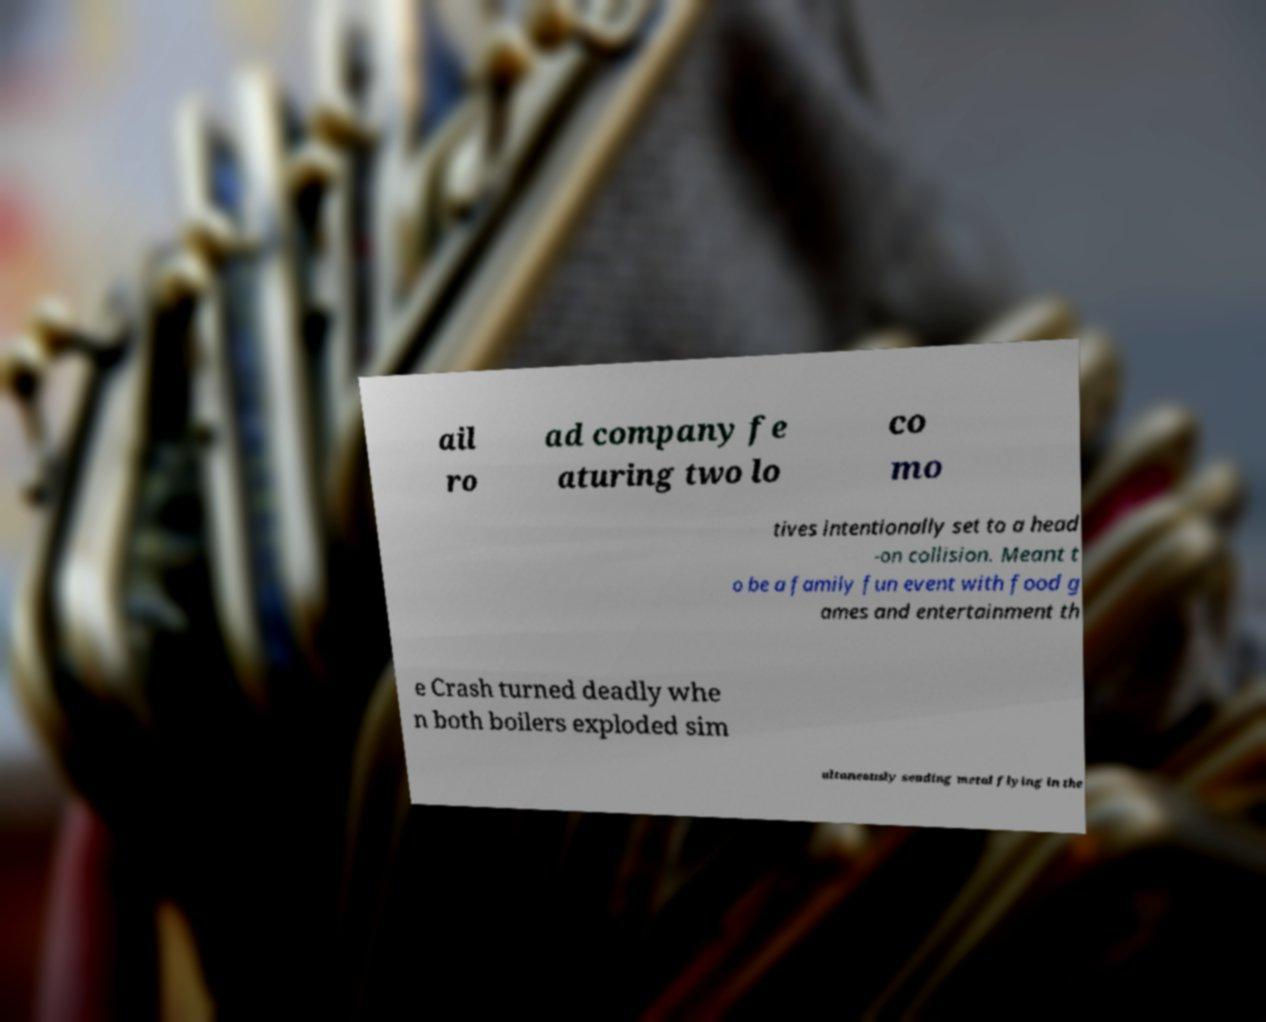For documentation purposes, I need the text within this image transcribed. Could you provide that? ail ro ad company fe aturing two lo co mo tives intentionally set to a head -on collision. Meant t o be a family fun event with food g ames and entertainment th e Crash turned deadly whe n both boilers exploded sim ultaneously sending metal flying in the 